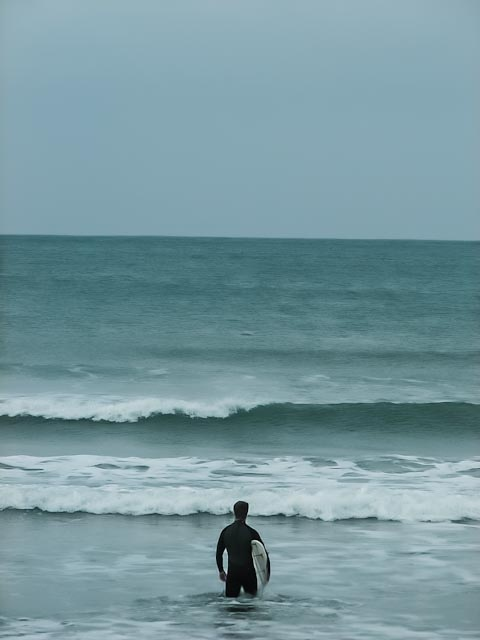Describe the objects in this image and their specific colors. I can see people in darkgray, black, gray, and purple tones and surfboard in darkgray, gray, and black tones in this image. 